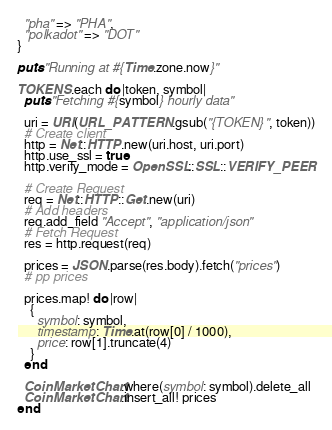Convert code to text. <code><loc_0><loc_0><loc_500><loc_500><_Ruby_>  "pha" => "PHA",
  "polkadot" => "DOT"
}

puts "Running at #{Time.zone.now}"

TOKENS.each do |token, symbol|
  puts "Fetching #{symbol} hourly data"

  uri = URI(URL_PATTERN.gsub("{TOKEN}", token))
  # Create client
  http = Net::HTTP.new(uri.host, uri.port)
  http.use_ssl = true
  http.verify_mode = OpenSSL::SSL::VERIFY_PEER

  # Create Request
  req = Net::HTTP::Get.new(uri)
  # Add headers
  req.add_field "Accept", "application/json"
  # Fetch Request
  res = http.request(req)

  prices = JSON.parse(res.body).fetch("prices")
  # pp prices

  prices.map! do |row|
    {
      symbol: symbol,
      timestamp: Time.at(row[0] / 1000),
      price: row[1].truncate(4)
    }
  end

  CoinMarketChart.where(symbol: symbol).delete_all
  CoinMarketChart.insert_all! prices
end
</code> 